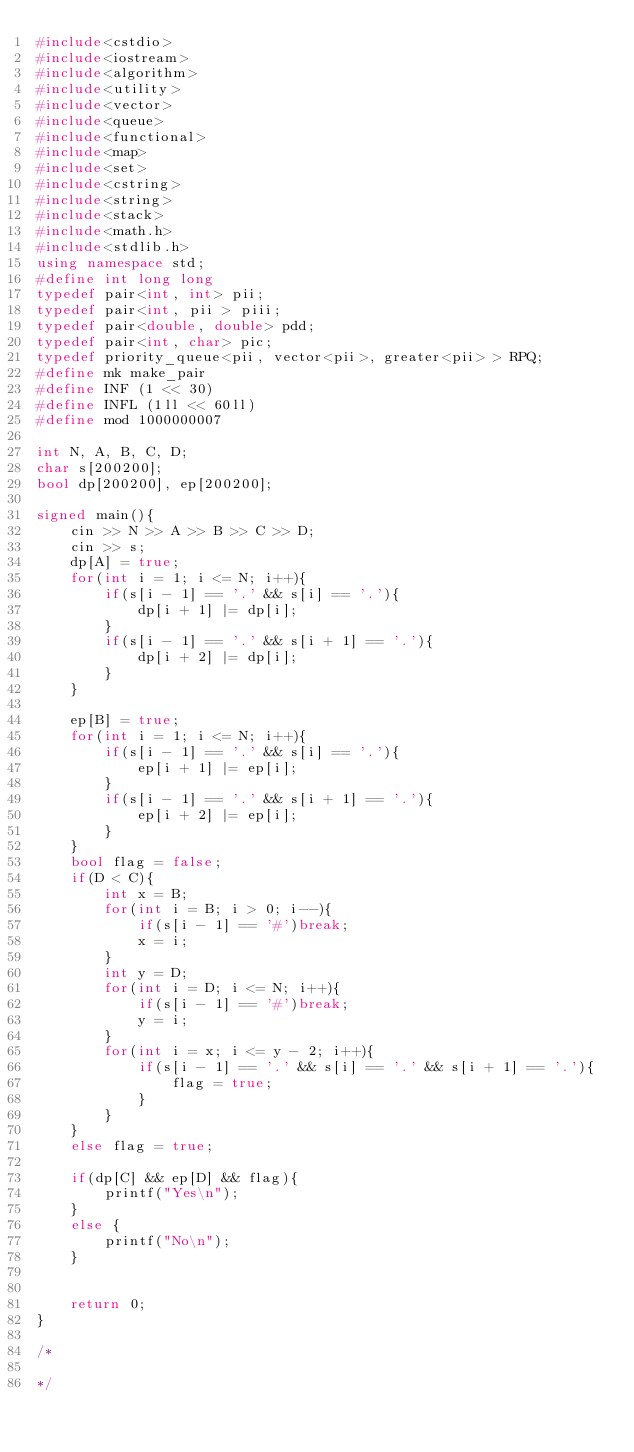Convert code to text. <code><loc_0><loc_0><loc_500><loc_500><_C++_>#include<cstdio>
#include<iostream>
#include<algorithm>
#include<utility>
#include<vector>
#include<queue>
#include<functional>
#include<map>
#include<set>
#include<cstring>
#include<string>
#include<stack>
#include<math.h>
#include<stdlib.h>
using namespace std;
#define int long long
typedef pair<int, int> pii;
typedef pair<int, pii > piii;
typedef pair<double, double> pdd;
typedef pair<int, char> pic;
typedef priority_queue<pii, vector<pii>, greater<pii> > RPQ;
#define mk make_pair
#define INF (1 << 30)
#define INFL (1ll << 60ll)
#define mod 1000000007

int N, A, B, C, D;
char s[200200];
bool dp[200200], ep[200200];

signed main(){
    cin >> N >> A >> B >> C >> D;
    cin >> s;
    dp[A] = true;
    for(int i = 1; i <= N; i++){
        if(s[i - 1] == '.' && s[i] == '.'){
            dp[i + 1] |= dp[i];
        }
        if(s[i - 1] == '.' && s[i + 1] == '.'){
            dp[i + 2] |= dp[i];
        }
    }
    
    ep[B] = true;
    for(int i = 1; i <= N; i++){
        if(s[i - 1] == '.' && s[i] == '.'){
            ep[i + 1] |= ep[i];
        }
        if(s[i - 1] == '.' && s[i + 1] == '.'){
            ep[i + 2] |= ep[i];
        }
    }
    bool flag = false;
    if(D < C){
        int x = B;
        for(int i = B; i > 0; i--){
            if(s[i - 1] == '#')break;
            x = i;
        }
        int y = D;
        for(int i = D; i <= N; i++){
            if(s[i - 1] == '#')break;
            y = i;
        }
        for(int i = x; i <= y - 2; i++){
            if(s[i - 1] == '.' && s[i] == '.' && s[i + 1] == '.'){
                flag = true;
            }
        }
    }
    else flag = true;

    if(dp[C] && ep[D] && flag){
        printf("Yes\n");
    }
    else {
        printf("No\n");
    }


    return 0;
}

/*

*/</code> 